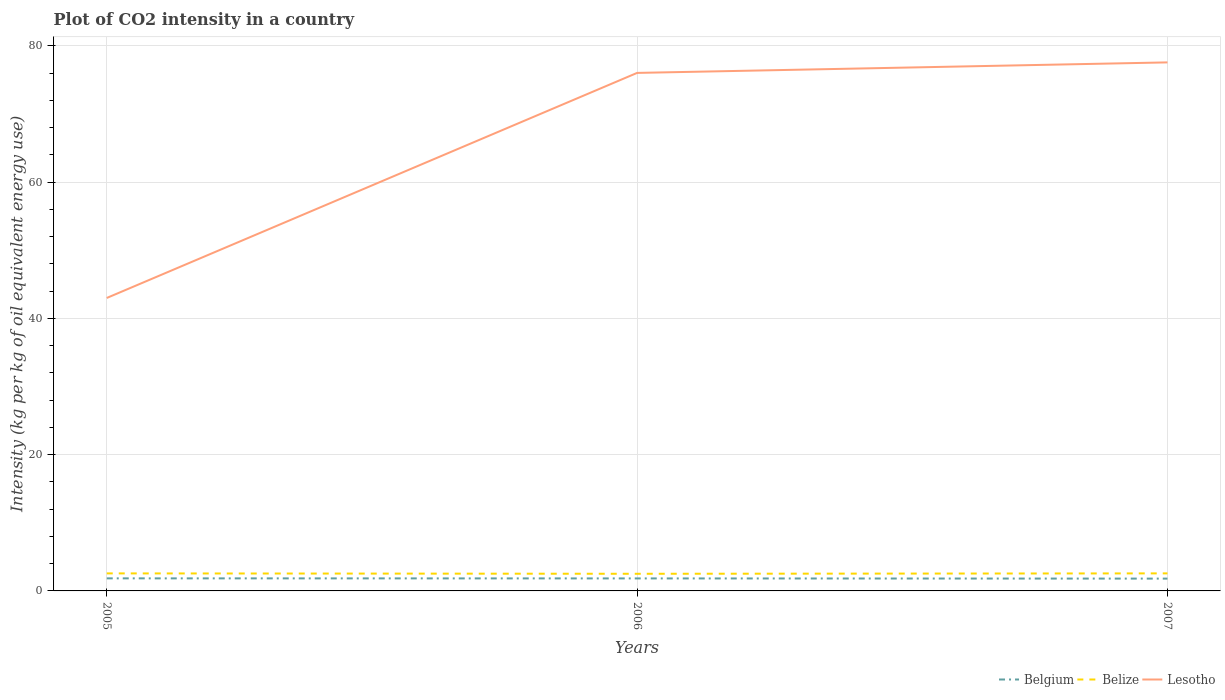Is the number of lines equal to the number of legend labels?
Provide a short and direct response. Yes. Across all years, what is the maximum CO2 intensity in in Belgium?
Your response must be concise. 1.81. In which year was the CO2 intensity in in Belize maximum?
Keep it short and to the point. 2006. What is the total CO2 intensity in in Belgium in the graph?
Offer a terse response. 0.03. What is the difference between the highest and the second highest CO2 intensity in in Belize?
Keep it short and to the point. 0.06. Is the CO2 intensity in in Belgium strictly greater than the CO2 intensity in in Belize over the years?
Keep it short and to the point. Yes. What is the difference between two consecutive major ticks on the Y-axis?
Offer a terse response. 20. Are the values on the major ticks of Y-axis written in scientific E-notation?
Ensure brevity in your answer.  No. Does the graph contain grids?
Give a very brief answer. Yes. Where does the legend appear in the graph?
Ensure brevity in your answer.  Bottom right. What is the title of the graph?
Your answer should be very brief. Plot of CO2 intensity in a country. What is the label or title of the Y-axis?
Provide a short and direct response. Intensity (kg per kg of oil equivalent energy use). What is the Intensity (kg per kg of oil equivalent energy use) in Belgium in 2005?
Offer a terse response. 1.84. What is the Intensity (kg per kg of oil equivalent energy use) in Belize in 2005?
Your answer should be very brief. 2.57. What is the Intensity (kg per kg of oil equivalent energy use) in Lesotho in 2005?
Provide a succinct answer. 43. What is the Intensity (kg per kg of oil equivalent energy use) in Belgium in 2006?
Your answer should be very brief. 1.83. What is the Intensity (kg per kg of oil equivalent energy use) of Belize in 2006?
Make the answer very short. 2.52. What is the Intensity (kg per kg of oil equivalent energy use) of Lesotho in 2006?
Ensure brevity in your answer.  76.04. What is the Intensity (kg per kg of oil equivalent energy use) in Belgium in 2007?
Provide a short and direct response. 1.81. What is the Intensity (kg per kg of oil equivalent energy use) in Belize in 2007?
Provide a succinct answer. 2.58. What is the Intensity (kg per kg of oil equivalent energy use) of Lesotho in 2007?
Your answer should be very brief. 77.59. Across all years, what is the maximum Intensity (kg per kg of oil equivalent energy use) in Belgium?
Offer a very short reply. 1.84. Across all years, what is the maximum Intensity (kg per kg of oil equivalent energy use) in Belize?
Provide a succinct answer. 2.58. Across all years, what is the maximum Intensity (kg per kg of oil equivalent energy use) in Lesotho?
Make the answer very short. 77.59. Across all years, what is the minimum Intensity (kg per kg of oil equivalent energy use) of Belgium?
Provide a succinct answer. 1.81. Across all years, what is the minimum Intensity (kg per kg of oil equivalent energy use) in Belize?
Your answer should be compact. 2.52. Across all years, what is the minimum Intensity (kg per kg of oil equivalent energy use) of Lesotho?
Provide a short and direct response. 43. What is the total Intensity (kg per kg of oil equivalent energy use) in Belgium in the graph?
Your answer should be compact. 5.49. What is the total Intensity (kg per kg of oil equivalent energy use) in Belize in the graph?
Ensure brevity in your answer.  7.66. What is the total Intensity (kg per kg of oil equivalent energy use) of Lesotho in the graph?
Offer a very short reply. 196.63. What is the difference between the Intensity (kg per kg of oil equivalent energy use) in Belgium in 2005 and that in 2006?
Keep it short and to the point. 0.01. What is the difference between the Intensity (kg per kg of oil equivalent energy use) in Belize in 2005 and that in 2006?
Offer a terse response. 0.06. What is the difference between the Intensity (kg per kg of oil equivalent energy use) of Lesotho in 2005 and that in 2006?
Your answer should be very brief. -33.04. What is the difference between the Intensity (kg per kg of oil equivalent energy use) in Belgium in 2005 and that in 2007?
Give a very brief answer. 0.04. What is the difference between the Intensity (kg per kg of oil equivalent energy use) of Belize in 2005 and that in 2007?
Provide a succinct answer. -0. What is the difference between the Intensity (kg per kg of oil equivalent energy use) of Lesotho in 2005 and that in 2007?
Your response must be concise. -34.58. What is the difference between the Intensity (kg per kg of oil equivalent energy use) of Belgium in 2006 and that in 2007?
Offer a very short reply. 0.03. What is the difference between the Intensity (kg per kg of oil equivalent energy use) in Belize in 2006 and that in 2007?
Ensure brevity in your answer.  -0.06. What is the difference between the Intensity (kg per kg of oil equivalent energy use) of Lesotho in 2006 and that in 2007?
Make the answer very short. -1.54. What is the difference between the Intensity (kg per kg of oil equivalent energy use) of Belgium in 2005 and the Intensity (kg per kg of oil equivalent energy use) of Belize in 2006?
Provide a short and direct response. -0.67. What is the difference between the Intensity (kg per kg of oil equivalent energy use) in Belgium in 2005 and the Intensity (kg per kg of oil equivalent energy use) in Lesotho in 2006?
Your answer should be compact. -74.2. What is the difference between the Intensity (kg per kg of oil equivalent energy use) of Belize in 2005 and the Intensity (kg per kg of oil equivalent energy use) of Lesotho in 2006?
Your answer should be compact. -73.47. What is the difference between the Intensity (kg per kg of oil equivalent energy use) in Belgium in 2005 and the Intensity (kg per kg of oil equivalent energy use) in Belize in 2007?
Your answer should be very brief. -0.73. What is the difference between the Intensity (kg per kg of oil equivalent energy use) of Belgium in 2005 and the Intensity (kg per kg of oil equivalent energy use) of Lesotho in 2007?
Your response must be concise. -75.74. What is the difference between the Intensity (kg per kg of oil equivalent energy use) in Belize in 2005 and the Intensity (kg per kg of oil equivalent energy use) in Lesotho in 2007?
Offer a terse response. -75.01. What is the difference between the Intensity (kg per kg of oil equivalent energy use) of Belgium in 2006 and the Intensity (kg per kg of oil equivalent energy use) of Belize in 2007?
Give a very brief answer. -0.74. What is the difference between the Intensity (kg per kg of oil equivalent energy use) of Belgium in 2006 and the Intensity (kg per kg of oil equivalent energy use) of Lesotho in 2007?
Ensure brevity in your answer.  -75.75. What is the difference between the Intensity (kg per kg of oil equivalent energy use) of Belize in 2006 and the Intensity (kg per kg of oil equivalent energy use) of Lesotho in 2007?
Make the answer very short. -75.07. What is the average Intensity (kg per kg of oil equivalent energy use) of Belgium per year?
Your answer should be very brief. 1.83. What is the average Intensity (kg per kg of oil equivalent energy use) in Belize per year?
Give a very brief answer. 2.55. What is the average Intensity (kg per kg of oil equivalent energy use) of Lesotho per year?
Provide a succinct answer. 65.54. In the year 2005, what is the difference between the Intensity (kg per kg of oil equivalent energy use) of Belgium and Intensity (kg per kg of oil equivalent energy use) of Belize?
Offer a very short reply. -0.73. In the year 2005, what is the difference between the Intensity (kg per kg of oil equivalent energy use) of Belgium and Intensity (kg per kg of oil equivalent energy use) of Lesotho?
Provide a short and direct response. -41.16. In the year 2005, what is the difference between the Intensity (kg per kg of oil equivalent energy use) in Belize and Intensity (kg per kg of oil equivalent energy use) in Lesotho?
Ensure brevity in your answer.  -40.43. In the year 2006, what is the difference between the Intensity (kg per kg of oil equivalent energy use) in Belgium and Intensity (kg per kg of oil equivalent energy use) in Belize?
Your answer should be compact. -0.68. In the year 2006, what is the difference between the Intensity (kg per kg of oil equivalent energy use) in Belgium and Intensity (kg per kg of oil equivalent energy use) in Lesotho?
Provide a short and direct response. -74.21. In the year 2006, what is the difference between the Intensity (kg per kg of oil equivalent energy use) in Belize and Intensity (kg per kg of oil equivalent energy use) in Lesotho?
Provide a succinct answer. -73.53. In the year 2007, what is the difference between the Intensity (kg per kg of oil equivalent energy use) in Belgium and Intensity (kg per kg of oil equivalent energy use) in Belize?
Your response must be concise. -0.77. In the year 2007, what is the difference between the Intensity (kg per kg of oil equivalent energy use) in Belgium and Intensity (kg per kg of oil equivalent energy use) in Lesotho?
Your answer should be compact. -75.78. In the year 2007, what is the difference between the Intensity (kg per kg of oil equivalent energy use) of Belize and Intensity (kg per kg of oil equivalent energy use) of Lesotho?
Offer a very short reply. -75.01. What is the ratio of the Intensity (kg per kg of oil equivalent energy use) of Belize in 2005 to that in 2006?
Ensure brevity in your answer.  1.02. What is the ratio of the Intensity (kg per kg of oil equivalent energy use) in Lesotho in 2005 to that in 2006?
Keep it short and to the point. 0.57. What is the ratio of the Intensity (kg per kg of oil equivalent energy use) in Lesotho in 2005 to that in 2007?
Make the answer very short. 0.55. What is the ratio of the Intensity (kg per kg of oil equivalent energy use) in Belgium in 2006 to that in 2007?
Offer a very short reply. 1.02. What is the ratio of the Intensity (kg per kg of oil equivalent energy use) in Belize in 2006 to that in 2007?
Provide a short and direct response. 0.98. What is the ratio of the Intensity (kg per kg of oil equivalent energy use) of Lesotho in 2006 to that in 2007?
Make the answer very short. 0.98. What is the difference between the highest and the second highest Intensity (kg per kg of oil equivalent energy use) of Belgium?
Your response must be concise. 0.01. What is the difference between the highest and the second highest Intensity (kg per kg of oil equivalent energy use) in Belize?
Your response must be concise. 0. What is the difference between the highest and the second highest Intensity (kg per kg of oil equivalent energy use) of Lesotho?
Provide a short and direct response. 1.54. What is the difference between the highest and the lowest Intensity (kg per kg of oil equivalent energy use) of Belgium?
Your response must be concise. 0.04. What is the difference between the highest and the lowest Intensity (kg per kg of oil equivalent energy use) in Belize?
Keep it short and to the point. 0.06. What is the difference between the highest and the lowest Intensity (kg per kg of oil equivalent energy use) in Lesotho?
Offer a terse response. 34.58. 